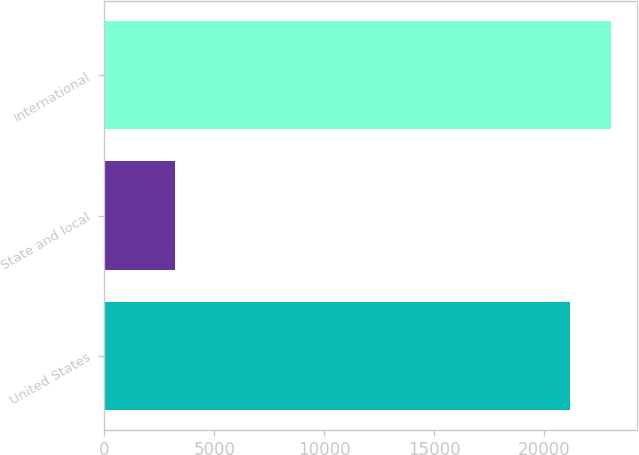Convert chart to OTSL. <chart><loc_0><loc_0><loc_500><loc_500><bar_chart><fcel>United States<fcel>State and local<fcel>International<nl><fcel>21198<fcel>3229<fcel>23059.9<nl></chart> 